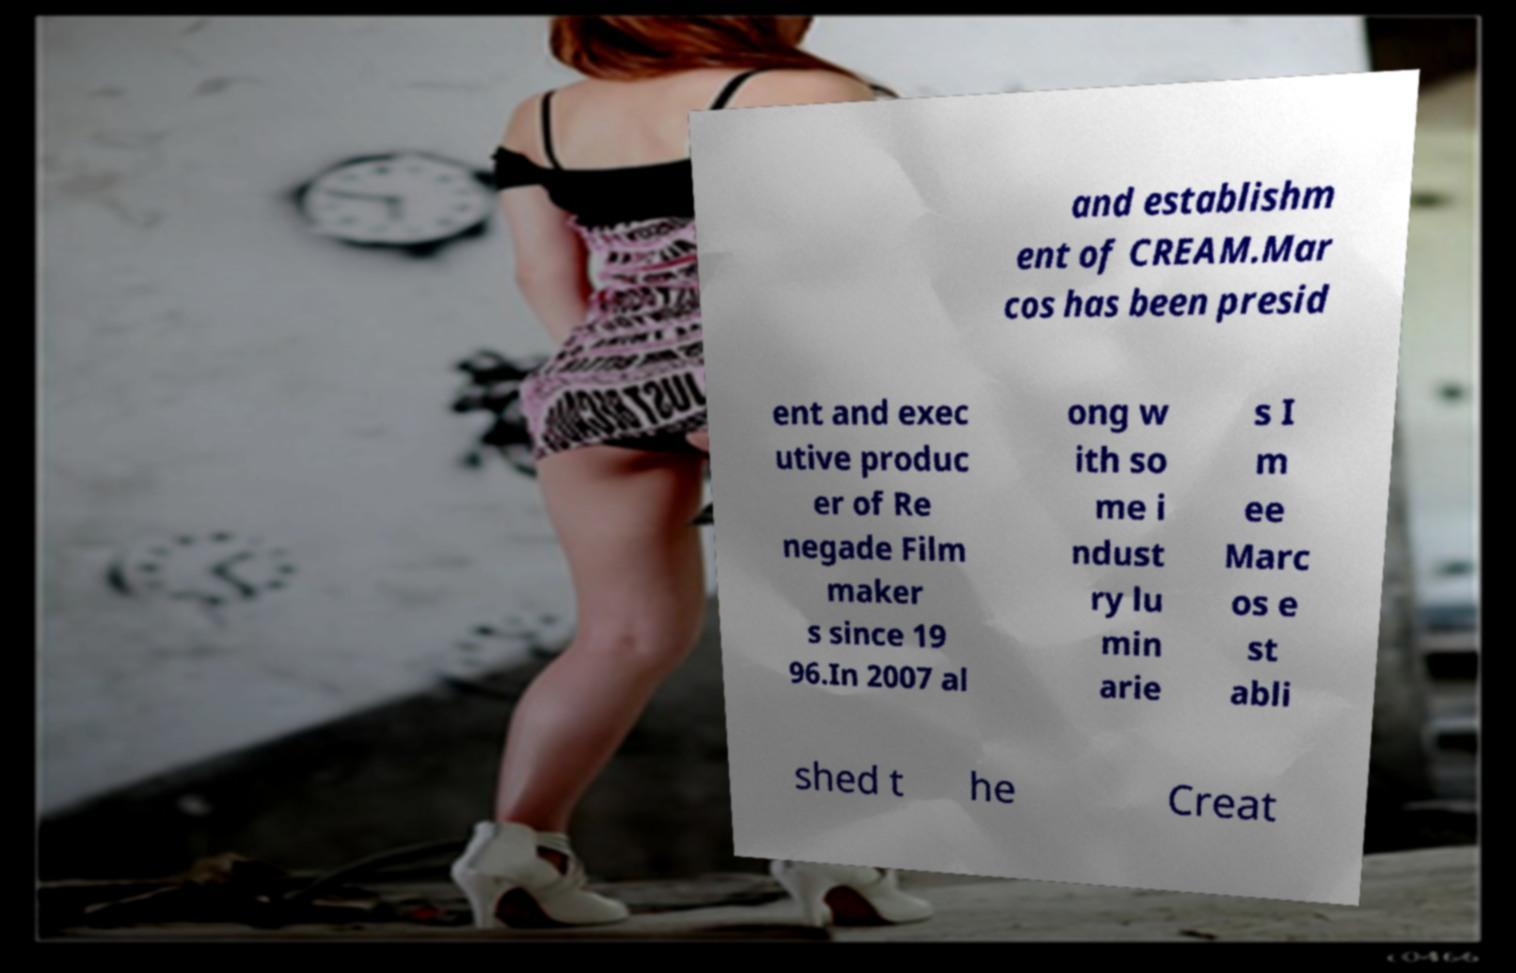Please identify and transcribe the text found in this image. and establishm ent of CREAM.Mar cos has been presid ent and exec utive produc er of Re negade Film maker s since 19 96.In 2007 al ong w ith so me i ndust ry lu min arie s I m ee Marc os e st abli shed t he Creat 